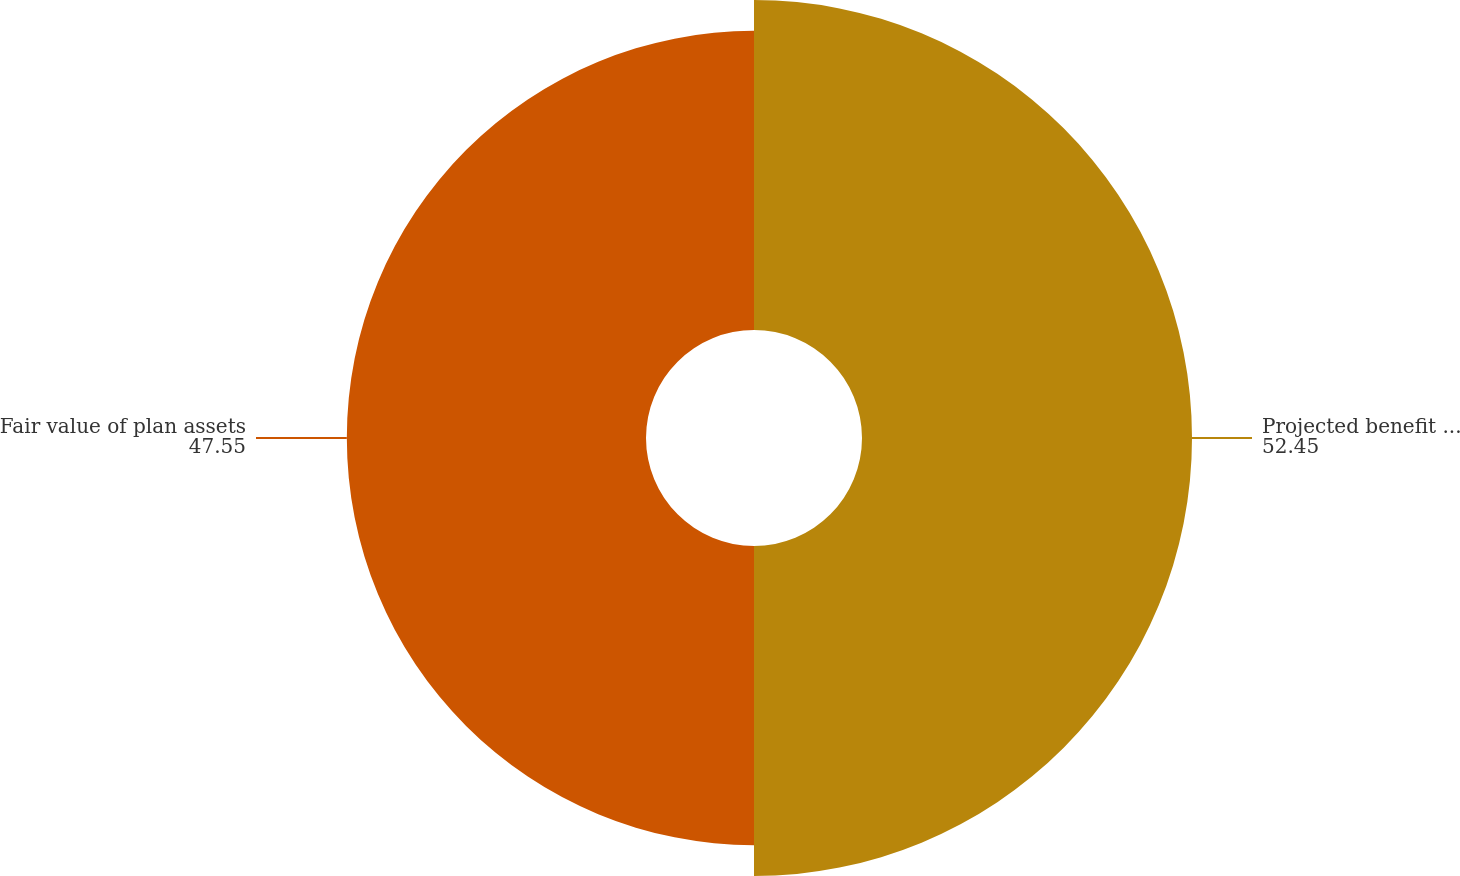<chart> <loc_0><loc_0><loc_500><loc_500><pie_chart><fcel>Projected benefit obligation<fcel>Fair value of plan assets<nl><fcel>52.45%<fcel>47.55%<nl></chart> 